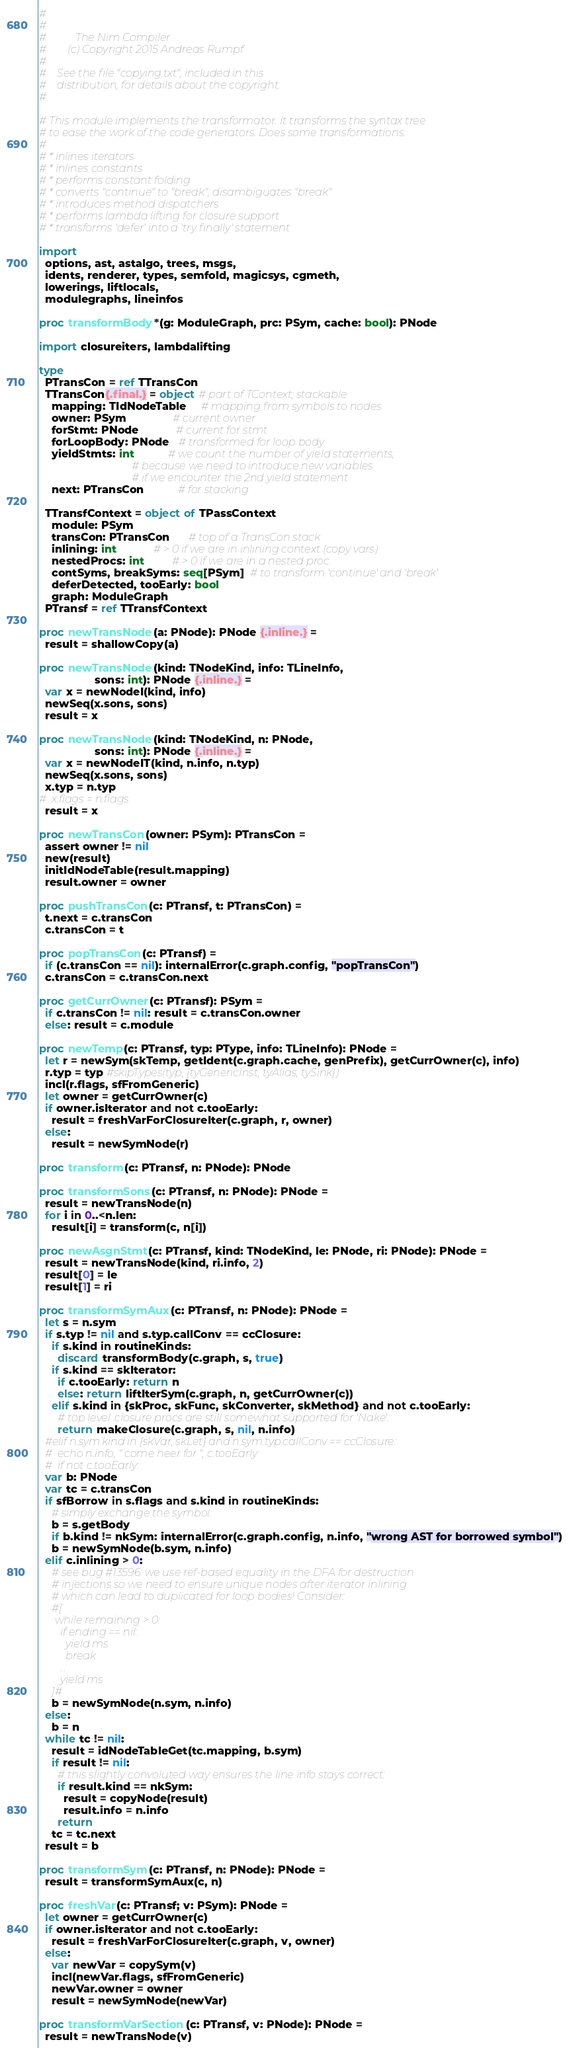<code> <loc_0><loc_0><loc_500><loc_500><_Nim_>#
#
#           The Nim Compiler
#        (c) Copyright 2015 Andreas Rumpf
#
#    See the file "copying.txt", included in this
#    distribution, for details about the copyright.
#

# This module implements the transformator. It transforms the syntax tree
# to ease the work of the code generators. Does some transformations:
#
# * inlines iterators
# * inlines constants
# * performs constant folding
# * converts "continue" to "break"; disambiguates "break"
# * introduces method dispatchers
# * performs lambda lifting for closure support
# * transforms 'defer' into a 'try finally' statement

import
  options, ast, astalgo, trees, msgs,
  idents, renderer, types, semfold, magicsys, cgmeth,
  lowerings, liftlocals,
  modulegraphs, lineinfos

proc transformBody*(g: ModuleGraph, prc: PSym, cache: bool): PNode

import closureiters, lambdalifting

type
  PTransCon = ref TTransCon
  TTransCon{.final.} = object # part of TContext; stackable
    mapping: TIdNodeTable     # mapping from symbols to nodes
    owner: PSym               # current owner
    forStmt: PNode            # current for stmt
    forLoopBody: PNode   # transformed for loop body
    yieldStmts: int           # we count the number of yield statements,
                              # because we need to introduce new variables
                              # if we encounter the 2nd yield statement
    next: PTransCon           # for stacking

  TTransfContext = object of TPassContext
    module: PSym
    transCon: PTransCon      # top of a TransCon stack
    inlining: int            # > 0 if we are in inlining context (copy vars)
    nestedProcs: int         # > 0 if we are in a nested proc
    contSyms, breakSyms: seq[PSym]  # to transform 'continue' and 'break'
    deferDetected, tooEarly: bool
    graph: ModuleGraph
  PTransf = ref TTransfContext

proc newTransNode(a: PNode): PNode {.inline.} =
  result = shallowCopy(a)

proc newTransNode(kind: TNodeKind, info: TLineInfo,
                  sons: int): PNode {.inline.} =
  var x = newNodeI(kind, info)
  newSeq(x.sons, sons)
  result = x

proc newTransNode(kind: TNodeKind, n: PNode,
                  sons: int): PNode {.inline.} =
  var x = newNodeIT(kind, n.info, n.typ)
  newSeq(x.sons, sons)
  x.typ = n.typ
#  x.flags = n.flags
  result = x

proc newTransCon(owner: PSym): PTransCon =
  assert owner != nil
  new(result)
  initIdNodeTable(result.mapping)
  result.owner = owner

proc pushTransCon(c: PTransf, t: PTransCon) =
  t.next = c.transCon
  c.transCon = t

proc popTransCon(c: PTransf) =
  if (c.transCon == nil): internalError(c.graph.config, "popTransCon")
  c.transCon = c.transCon.next

proc getCurrOwner(c: PTransf): PSym =
  if c.transCon != nil: result = c.transCon.owner
  else: result = c.module

proc newTemp(c: PTransf, typ: PType, info: TLineInfo): PNode =
  let r = newSym(skTemp, getIdent(c.graph.cache, genPrefix), getCurrOwner(c), info)
  r.typ = typ #skipTypes(typ, {tyGenericInst, tyAlias, tySink})
  incl(r.flags, sfFromGeneric)
  let owner = getCurrOwner(c)
  if owner.isIterator and not c.tooEarly:
    result = freshVarForClosureIter(c.graph, r, owner)
  else:
    result = newSymNode(r)

proc transform(c: PTransf, n: PNode): PNode

proc transformSons(c: PTransf, n: PNode): PNode =
  result = newTransNode(n)
  for i in 0..<n.len:
    result[i] = transform(c, n[i])

proc newAsgnStmt(c: PTransf, kind: TNodeKind, le: PNode, ri: PNode): PNode =
  result = newTransNode(kind, ri.info, 2)
  result[0] = le
  result[1] = ri

proc transformSymAux(c: PTransf, n: PNode): PNode =
  let s = n.sym
  if s.typ != nil and s.typ.callConv == ccClosure:
    if s.kind in routineKinds:
      discard transformBody(c.graph, s, true)
    if s.kind == skIterator:
      if c.tooEarly: return n
      else: return liftIterSym(c.graph, n, getCurrOwner(c))
    elif s.kind in {skProc, skFunc, skConverter, skMethod} and not c.tooEarly:
      # top level .closure procs are still somewhat supported for 'Nake':
      return makeClosure(c.graph, s, nil, n.info)
  #elif n.sym.kind in {skVar, skLet} and n.sym.typ.callConv == ccClosure:
  #  echo n.info, " come heer for ", c.tooEarly
  #  if not c.tooEarly:
  var b: PNode
  var tc = c.transCon
  if sfBorrow in s.flags and s.kind in routineKinds:
    # simply exchange the symbol:
    b = s.getBody
    if b.kind != nkSym: internalError(c.graph.config, n.info, "wrong AST for borrowed symbol")
    b = newSymNode(b.sym, n.info)
  elif c.inlining > 0:
    # see bug #13596: we use ref-based equality in the DFA for destruction
    # injections so we need to ensure unique nodes after iterator inlining
    # which can lead to duplicated for loop bodies! Consider:
    #[
      while remaining > 0:
        if ending == nil:
          yield ms
          break
        ...
        yield ms
    ]#
    b = newSymNode(n.sym, n.info)
  else:
    b = n
  while tc != nil:
    result = idNodeTableGet(tc.mapping, b.sym)
    if result != nil:
      # this slightly convoluted way ensures the line info stays correct:
      if result.kind == nkSym:
        result = copyNode(result)
        result.info = n.info
      return
    tc = tc.next
  result = b

proc transformSym(c: PTransf, n: PNode): PNode =
  result = transformSymAux(c, n)

proc freshVar(c: PTransf; v: PSym): PNode =
  let owner = getCurrOwner(c)
  if owner.isIterator and not c.tooEarly:
    result = freshVarForClosureIter(c.graph, v, owner)
  else:
    var newVar = copySym(v)
    incl(newVar.flags, sfFromGeneric)
    newVar.owner = owner
    result = newSymNode(newVar)

proc transformVarSection(c: PTransf, v: PNode): PNode =
  result = newTransNode(v)</code> 